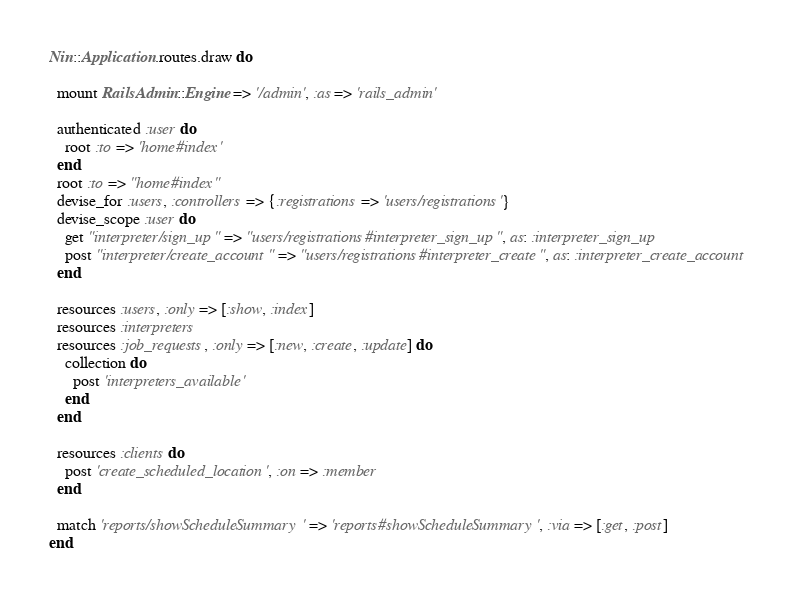<code> <loc_0><loc_0><loc_500><loc_500><_Ruby_>Nin::Application.routes.draw do

  mount RailsAdmin::Engine => '/admin', :as => 'rails_admin'

  authenticated :user do
    root :to => 'home#index'
  end
  root :to => "home#index"
  devise_for :users, :controllers => {:registrations => 'users/registrations'}
  devise_scope :user do
    get "interpreter/sign_up" => "users/registrations#interpreter_sign_up", as: :interpreter_sign_up
    post "interpreter/create_account" => "users/registrations#interpreter_create", as: :interpreter_create_account
  end

  resources :users, :only => [:show, :index]
  resources :interpreters
  resources :job_requests, :only => [:new, :create, :update] do
    collection do
      post 'interpreters_available'
    end
  end

  resources :clients do
    post 'create_scheduled_location', :on => :member
  end

  match 'reports/showScheduleSummary' => 'reports#showScheduleSummary', :via => [:get, :post]
end
</code> 